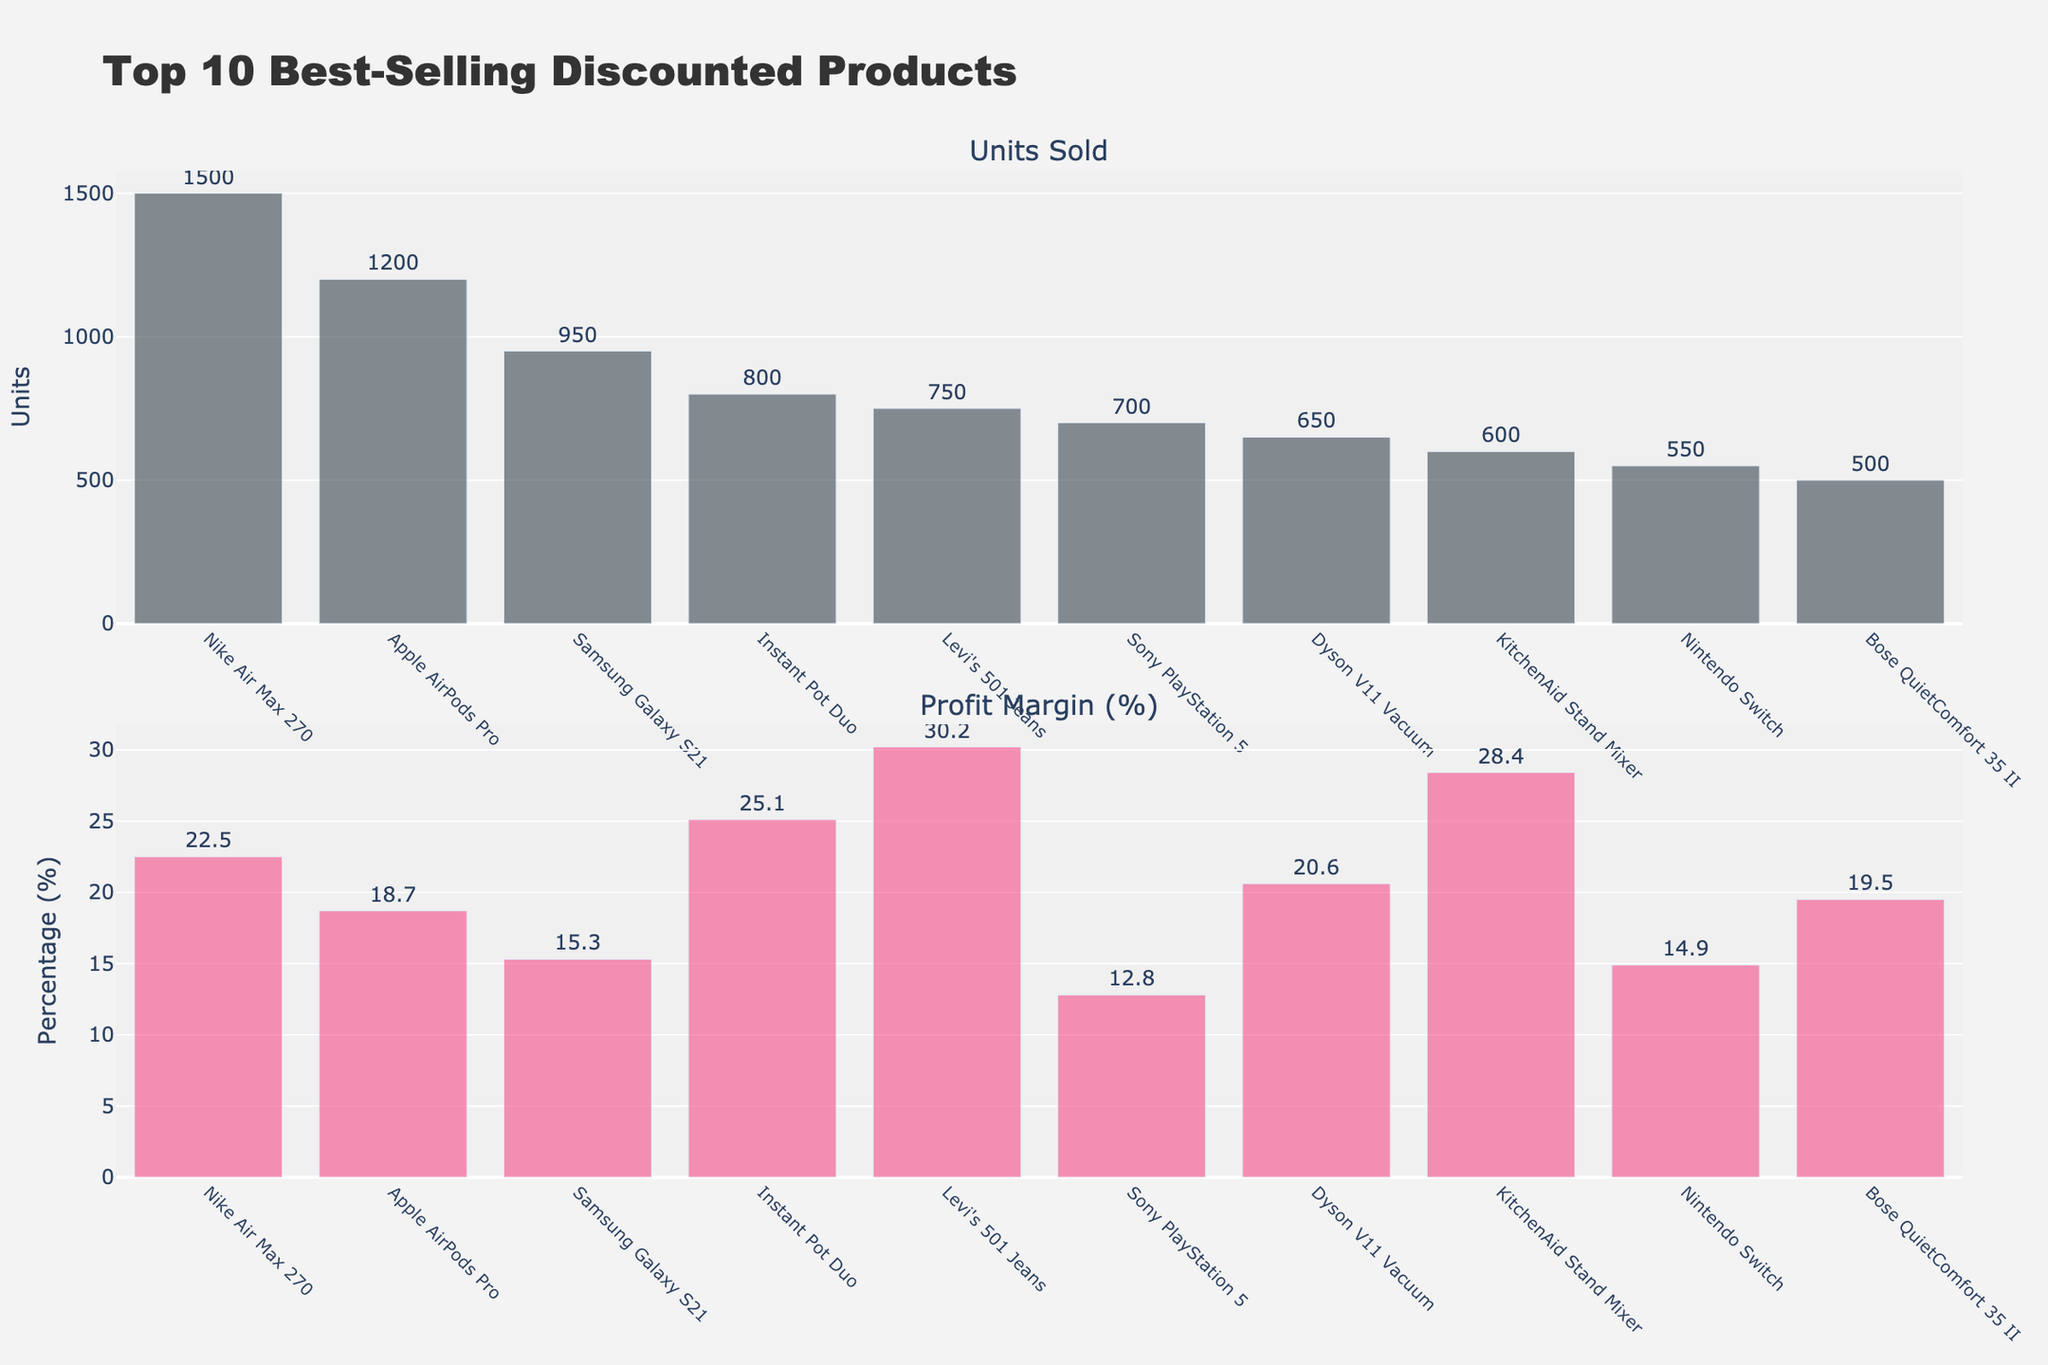What is the title of the figure? The title of a figure is typically located at the top and describes the overall content being depicted in the chart. In this case, the title reads "Top 10 Best-Selling Discounted Products."
Answer: Top 10 Best-Selling Discounted Products Which product has the highest unit sales? To find which product has the highest unit sales, look at the bar with the tallest height in the "Units Sold" subplot. "Nike Air Max 270" has the highest unit sales with 1500 units sold.
Answer: Nike Air Max 270 How many units of Levi's 501 Jeans were sold? Refer to the "Units Sold" subplot and find the bar corresponding to "Levi's 501 Jeans." The label on the bar indicates the number of units sold, which is 750.
Answer: 750 Which product has the lowest profit margin and what is it? Look at the second subplot titled "Profit Margin (%)" and identify the smallest bar. The product with the lowest profit margin is "Sony PlayStation 5" at 12.8%.
Answer: Sony PlayStation 5, 12.8% What is the difference in profit margin between KitchenAid Stand Mixer and Bose QuietComfort 35 II? In the "Profit Margin (%)" subplot, find the bars for "KitchenAid Stand Mixer" and "Bose QuietComfort 35 II." The profit margins are 28.4% and 19.5%, respectively. The difference is 28.4 - 19.5 = 8.9%.
Answer: 8.9% Which products have profit margins above 20%? Check the "Profit Margin (%)" subplot for bars higher than 20%. The products with profit margins above 20% are Nike Air Max 270 (22.5%), Instant Pot Duo (25.1%), Levi's 501 Jeans (30.2%), KitchenAid Stand Mixer (28.4%), and Dyson V11 Vacuum (20.6%).
Answer: Nike Air Max 270, Instant Pot Duo, Levi's 501 Jeans, KitchenAid Stand Mixer, Dyson V11 Vacuum Is the profit margin of Apple AirPods Pro higher or lower than that of Dyson V11 Vacuum? In the "Profit Margin (%)" subplot, compare the bars for "Apple AirPods Pro" and "Dyson V11 Vacuum." The profit margin for Apple AirPods Pro is 18.7% and for Dyson V11 Vacuum is 20.6%, indicating that Apple AirPods Pro has a lower profit margin.
Answer: Lower What is the average profit margin of the top 5 best-selling products? First, identify the top 5 best-selling products from the "Units Sold" subplot (Nike Air Max 270, Apple AirPods Pro, Samsung Galaxy S21, Instant Pot Duo, Levi's 501 Jeans). Their profit margins are 22.5%, 18.7%, 15.3%, 25.1%, and 30.2%, respectively. Calculate the average: (22.5 + 18.7 + 15.3 + 25.1 + 30.2) / 5 = 22.36%.
Answer: 22.36% Which product has a higher unit sale, Nintendo Switch or Sony PlayStation 5? In the "Units Sold" subplot, compare the bars for "Nintendo Switch" and "Sony PlayStation 5." The numbers indicate that Sony PlayStation 5 has higher unit sales (700 units) compared to Nintendo Switch (550 units).
Answer: Sony PlayStation 5 How does the profit margin of Nintendo Switch compare to Instant Pot Duo? Check the "Profit Margin (%)" subplot for Nintendo Switch and Instant Pot Duo. The profit margins are 14.9% and 25.1%, respectively. Instant Pot Duo has a higher profit margin.
Answer: Higher 